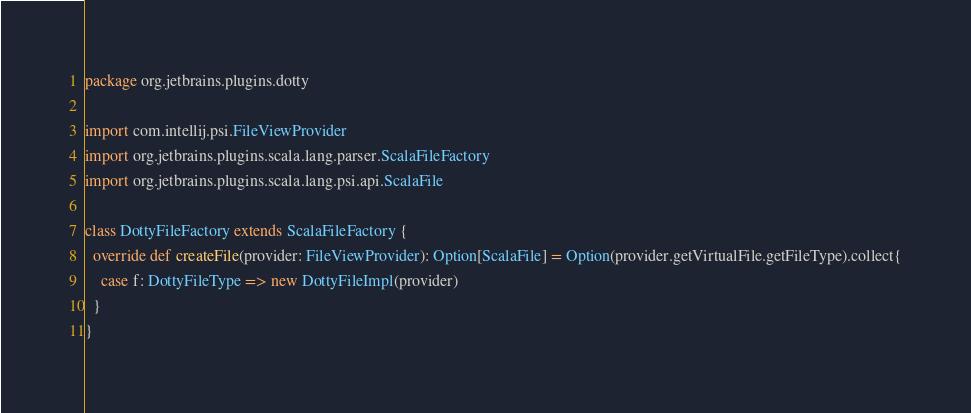<code> <loc_0><loc_0><loc_500><loc_500><_Scala_>package org.jetbrains.plugins.dotty

import com.intellij.psi.FileViewProvider
import org.jetbrains.plugins.scala.lang.parser.ScalaFileFactory
import org.jetbrains.plugins.scala.lang.psi.api.ScalaFile

class DottyFileFactory extends ScalaFileFactory {
  override def createFile(provider: FileViewProvider): Option[ScalaFile] = Option(provider.getVirtualFile.getFileType).collect{
    case f: DottyFileType => new DottyFileImpl(provider)
  }
}
</code> 